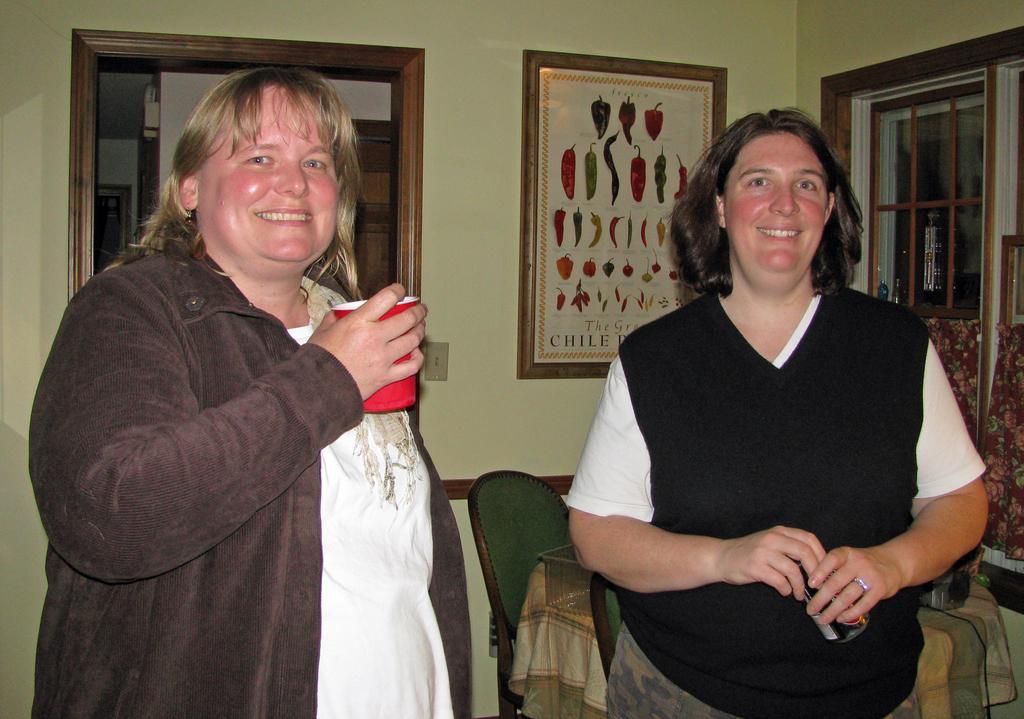Can you describe this image briefly? Here we can see two persons are standing and smiling, and at back here is the wall and photo frame on it, and here is the window, and here is the door. 